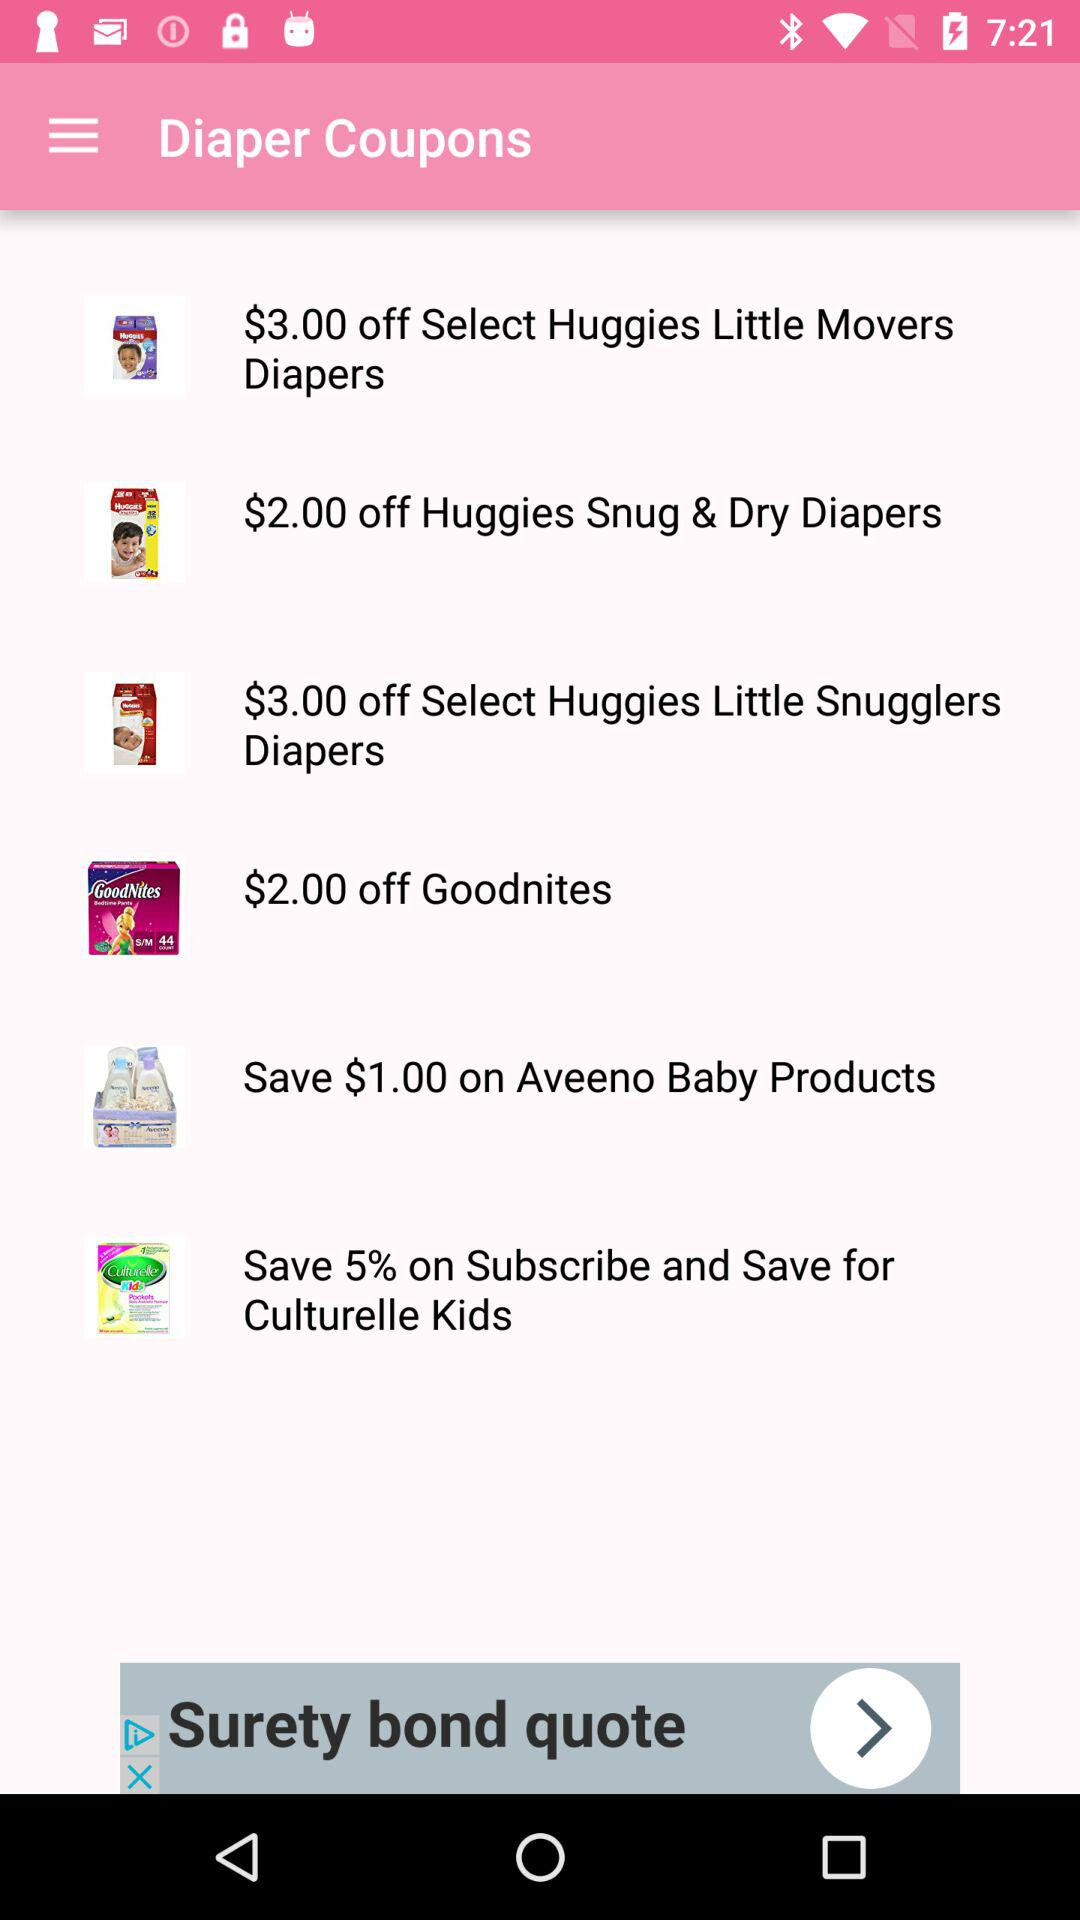What is the currency for the amount that can be saved? The currency for the amount that can be saved is dollars. 